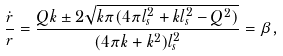Convert formula to latex. <formula><loc_0><loc_0><loc_500><loc_500>\frac { \dot { r } } { r } = \frac { Q k \pm 2 \sqrt { k \pi ( 4 \pi l _ { s } ^ { 2 } + k l _ { s } ^ { 2 } - Q ^ { 2 } ) } } { ( 4 \pi k + k ^ { 2 } ) l _ { s } ^ { 2 } } = \beta ,</formula> 